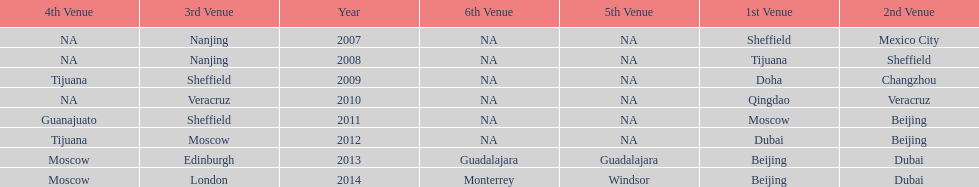In what year was the 3rd venue the same as 2011's 1st venue? 2012. 